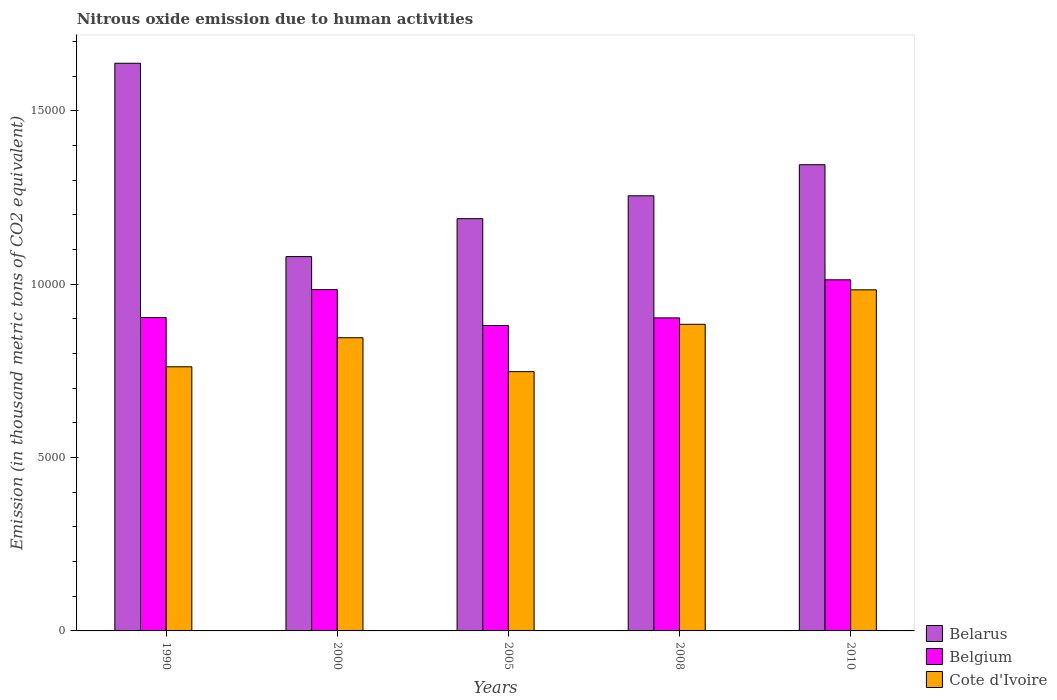What is the amount of nitrous oxide emitted in Belgium in 2010?
Your response must be concise. 1.01e+04. Across all years, what is the maximum amount of nitrous oxide emitted in Belarus?
Offer a very short reply. 1.64e+04. Across all years, what is the minimum amount of nitrous oxide emitted in Cote d'Ivoire?
Your response must be concise. 7477.7. In which year was the amount of nitrous oxide emitted in Belgium maximum?
Offer a terse response. 2010. In which year was the amount of nitrous oxide emitted in Belarus minimum?
Your answer should be compact. 2000. What is the total amount of nitrous oxide emitted in Belgium in the graph?
Make the answer very short. 4.68e+04. What is the difference between the amount of nitrous oxide emitted in Belarus in 2005 and that in 2010?
Give a very brief answer. -1555.5. What is the difference between the amount of nitrous oxide emitted in Belgium in 2000 and the amount of nitrous oxide emitted in Belarus in 2010?
Offer a very short reply. -3601.6. What is the average amount of nitrous oxide emitted in Belarus per year?
Offer a terse response. 1.30e+04. In the year 1990, what is the difference between the amount of nitrous oxide emitted in Cote d'Ivoire and amount of nitrous oxide emitted in Belarus?
Make the answer very short. -8754.3. In how many years, is the amount of nitrous oxide emitted in Belgium greater than 2000 thousand metric tons?
Your answer should be compact. 5. What is the ratio of the amount of nitrous oxide emitted in Belgium in 2000 to that in 2008?
Keep it short and to the point. 1.09. Is the amount of nitrous oxide emitted in Cote d'Ivoire in 1990 less than that in 2010?
Offer a terse response. Yes. Is the difference between the amount of nitrous oxide emitted in Cote d'Ivoire in 2008 and 2010 greater than the difference between the amount of nitrous oxide emitted in Belarus in 2008 and 2010?
Provide a short and direct response. No. What is the difference between the highest and the second highest amount of nitrous oxide emitted in Belgium?
Offer a terse response. 282.7. What is the difference between the highest and the lowest amount of nitrous oxide emitted in Belgium?
Give a very brief answer. 1318.2. In how many years, is the amount of nitrous oxide emitted in Cote d'Ivoire greater than the average amount of nitrous oxide emitted in Cote d'Ivoire taken over all years?
Offer a terse response. 3. Is the sum of the amount of nitrous oxide emitted in Belgium in 1990 and 2010 greater than the maximum amount of nitrous oxide emitted in Cote d'Ivoire across all years?
Your answer should be very brief. Yes. What does the 2nd bar from the left in 2000 represents?
Keep it short and to the point. Belgium. How many bars are there?
Ensure brevity in your answer.  15. What is the difference between two consecutive major ticks on the Y-axis?
Make the answer very short. 5000. Are the values on the major ticks of Y-axis written in scientific E-notation?
Ensure brevity in your answer.  No. Does the graph contain grids?
Provide a short and direct response. No. Where does the legend appear in the graph?
Make the answer very short. Bottom right. How many legend labels are there?
Keep it short and to the point. 3. How are the legend labels stacked?
Keep it short and to the point. Vertical. What is the title of the graph?
Ensure brevity in your answer.  Nitrous oxide emission due to human activities. Does "Nepal" appear as one of the legend labels in the graph?
Offer a very short reply. No. What is the label or title of the X-axis?
Provide a short and direct response. Years. What is the label or title of the Y-axis?
Offer a terse response. Emission (in thousand metric tons of CO2 equivalent). What is the Emission (in thousand metric tons of CO2 equivalent) of Belarus in 1990?
Offer a very short reply. 1.64e+04. What is the Emission (in thousand metric tons of CO2 equivalent) in Belgium in 1990?
Your answer should be very brief. 9037.7. What is the Emission (in thousand metric tons of CO2 equivalent) in Cote d'Ivoire in 1990?
Provide a short and direct response. 7618. What is the Emission (in thousand metric tons of CO2 equivalent) in Belarus in 2000?
Your answer should be compact. 1.08e+04. What is the Emission (in thousand metric tons of CO2 equivalent) in Belgium in 2000?
Provide a short and direct response. 9844.1. What is the Emission (in thousand metric tons of CO2 equivalent) in Cote d'Ivoire in 2000?
Ensure brevity in your answer.  8455.7. What is the Emission (in thousand metric tons of CO2 equivalent) in Belarus in 2005?
Give a very brief answer. 1.19e+04. What is the Emission (in thousand metric tons of CO2 equivalent) in Belgium in 2005?
Offer a very short reply. 8808.6. What is the Emission (in thousand metric tons of CO2 equivalent) in Cote d'Ivoire in 2005?
Keep it short and to the point. 7477.7. What is the Emission (in thousand metric tons of CO2 equivalent) of Belarus in 2008?
Ensure brevity in your answer.  1.25e+04. What is the Emission (in thousand metric tons of CO2 equivalent) of Belgium in 2008?
Offer a terse response. 9028.7. What is the Emission (in thousand metric tons of CO2 equivalent) in Cote d'Ivoire in 2008?
Provide a short and direct response. 8843.3. What is the Emission (in thousand metric tons of CO2 equivalent) in Belarus in 2010?
Make the answer very short. 1.34e+04. What is the Emission (in thousand metric tons of CO2 equivalent) in Belgium in 2010?
Provide a succinct answer. 1.01e+04. What is the Emission (in thousand metric tons of CO2 equivalent) of Cote d'Ivoire in 2010?
Provide a succinct answer. 9837.4. Across all years, what is the maximum Emission (in thousand metric tons of CO2 equivalent) of Belarus?
Offer a terse response. 1.64e+04. Across all years, what is the maximum Emission (in thousand metric tons of CO2 equivalent) in Belgium?
Keep it short and to the point. 1.01e+04. Across all years, what is the maximum Emission (in thousand metric tons of CO2 equivalent) in Cote d'Ivoire?
Provide a short and direct response. 9837.4. Across all years, what is the minimum Emission (in thousand metric tons of CO2 equivalent) of Belarus?
Your answer should be very brief. 1.08e+04. Across all years, what is the minimum Emission (in thousand metric tons of CO2 equivalent) in Belgium?
Your answer should be very brief. 8808.6. Across all years, what is the minimum Emission (in thousand metric tons of CO2 equivalent) in Cote d'Ivoire?
Make the answer very short. 7477.7. What is the total Emission (in thousand metric tons of CO2 equivalent) in Belarus in the graph?
Ensure brevity in your answer.  6.51e+04. What is the total Emission (in thousand metric tons of CO2 equivalent) of Belgium in the graph?
Your answer should be very brief. 4.68e+04. What is the total Emission (in thousand metric tons of CO2 equivalent) of Cote d'Ivoire in the graph?
Offer a very short reply. 4.22e+04. What is the difference between the Emission (in thousand metric tons of CO2 equivalent) in Belarus in 1990 and that in 2000?
Your response must be concise. 5576.4. What is the difference between the Emission (in thousand metric tons of CO2 equivalent) in Belgium in 1990 and that in 2000?
Offer a terse response. -806.4. What is the difference between the Emission (in thousand metric tons of CO2 equivalent) of Cote d'Ivoire in 1990 and that in 2000?
Your answer should be very brief. -837.7. What is the difference between the Emission (in thousand metric tons of CO2 equivalent) of Belarus in 1990 and that in 2005?
Offer a very short reply. 4482.1. What is the difference between the Emission (in thousand metric tons of CO2 equivalent) of Belgium in 1990 and that in 2005?
Your response must be concise. 229.1. What is the difference between the Emission (in thousand metric tons of CO2 equivalent) in Cote d'Ivoire in 1990 and that in 2005?
Keep it short and to the point. 140.3. What is the difference between the Emission (in thousand metric tons of CO2 equivalent) in Belarus in 1990 and that in 2008?
Make the answer very short. 3822.4. What is the difference between the Emission (in thousand metric tons of CO2 equivalent) of Belgium in 1990 and that in 2008?
Offer a terse response. 9. What is the difference between the Emission (in thousand metric tons of CO2 equivalent) of Cote d'Ivoire in 1990 and that in 2008?
Your answer should be compact. -1225.3. What is the difference between the Emission (in thousand metric tons of CO2 equivalent) in Belarus in 1990 and that in 2010?
Give a very brief answer. 2926.6. What is the difference between the Emission (in thousand metric tons of CO2 equivalent) in Belgium in 1990 and that in 2010?
Your answer should be very brief. -1089.1. What is the difference between the Emission (in thousand metric tons of CO2 equivalent) of Cote d'Ivoire in 1990 and that in 2010?
Your answer should be very brief. -2219.4. What is the difference between the Emission (in thousand metric tons of CO2 equivalent) in Belarus in 2000 and that in 2005?
Your answer should be very brief. -1094.3. What is the difference between the Emission (in thousand metric tons of CO2 equivalent) in Belgium in 2000 and that in 2005?
Your response must be concise. 1035.5. What is the difference between the Emission (in thousand metric tons of CO2 equivalent) of Cote d'Ivoire in 2000 and that in 2005?
Provide a short and direct response. 978. What is the difference between the Emission (in thousand metric tons of CO2 equivalent) in Belarus in 2000 and that in 2008?
Provide a short and direct response. -1754. What is the difference between the Emission (in thousand metric tons of CO2 equivalent) in Belgium in 2000 and that in 2008?
Provide a succinct answer. 815.4. What is the difference between the Emission (in thousand metric tons of CO2 equivalent) in Cote d'Ivoire in 2000 and that in 2008?
Give a very brief answer. -387.6. What is the difference between the Emission (in thousand metric tons of CO2 equivalent) of Belarus in 2000 and that in 2010?
Give a very brief answer. -2649.8. What is the difference between the Emission (in thousand metric tons of CO2 equivalent) of Belgium in 2000 and that in 2010?
Your response must be concise. -282.7. What is the difference between the Emission (in thousand metric tons of CO2 equivalent) of Cote d'Ivoire in 2000 and that in 2010?
Provide a short and direct response. -1381.7. What is the difference between the Emission (in thousand metric tons of CO2 equivalent) in Belarus in 2005 and that in 2008?
Your answer should be very brief. -659.7. What is the difference between the Emission (in thousand metric tons of CO2 equivalent) of Belgium in 2005 and that in 2008?
Offer a terse response. -220.1. What is the difference between the Emission (in thousand metric tons of CO2 equivalent) in Cote d'Ivoire in 2005 and that in 2008?
Your answer should be very brief. -1365.6. What is the difference between the Emission (in thousand metric tons of CO2 equivalent) in Belarus in 2005 and that in 2010?
Keep it short and to the point. -1555.5. What is the difference between the Emission (in thousand metric tons of CO2 equivalent) of Belgium in 2005 and that in 2010?
Your answer should be compact. -1318.2. What is the difference between the Emission (in thousand metric tons of CO2 equivalent) of Cote d'Ivoire in 2005 and that in 2010?
Keep it short and to the point. -2359.7. What is the difference between the Emission (in thousand metric tons of CO2 equivalent) in Belarus in 2008 and that in 2010?
Your answer should be very brief. -895.8. What is the difference between the Emission (in thousand metric tons of CO2 equivalent) in Belgium in 2008 and that in 2010?
Ensure brevity in your answer.  -1098.1. What is the difference between the Emission (in thousand metric tons of CO2 equivalent) in Cote d'Ivoire in 2008 and that in 2010?
Your answer should be very brief. -994.1. What is the difference between the Emission (in thousand metric tons of CO2 equivalent) of Belarus in 1990 and the Emission (in thousand metric tons of CO2 equivalent) of Belgium in 2000?
Your response must be concise. 6528.2. What is the difference between the Emission (in thousand metric tons of CO2 equivalent) in Belarus in 1990 and the Emission (in thousand metric tons of CO2 equivalent) in Cote d'Ivoire in 2000?
Your answer should be compact. 7916.6. What is the difference between the Emission (in thousand metric tons of CO2 equivalent) of Belgium in 1990 and the Emission (in thousand metric tons of CO2 equivalent) of Cote d'Ivoire in 2000?
Your response must be concise. 582. What is the difference between the Emission (in thousand metric tons of CO2 equivalent) in Belarus in 1990 and the Emission (in thousand metric tons of CO2 equivalent) in Belgium in 2005?
Your answer should be compact. 7563.7. What is the difference between the Emission (in thousand metric tons of CO2 equivalent) of Belarus in 1990 and the Emission (in thousand metric tons of CO2 equivalent) of Cote d'Ivoire in 2005?
Ensure brevity in your answer.  8894.6. What is the difference between the Emission (in thousand metric tons of CO2 equivalent) of Belgium in 1990 and the Emission (in thousand metric tons of CO2 equivalent) of Cote d'Ivoire in 2005?
Ensure brevity in your answer.  1560. What is the difference between the Emission (in thousand metric tons of CO2 equivalent) of Belarus in 1990 and the Emission (in thousand metric tons of CO2 equivalent) of Belgium in 2008?
Your response must be concise. 7343.6. What is the difference between the Emission (in thousand metric tons of CO2 equivalent) in Belarus in 1990 and the Emission (in thousand metric tons of CO2 equivalent) in Cote d'Ivoire in 2008?
Provide a short and direct response. 7529. What is the difference between the Emission (in thousand metric tons of CO2 equivalent) of Belgium in 1990 and the Emission (in thousand metric tons of CO2 equivalent) of Cote d'Ivoire in 2008?
Make the answer very short. 194.4. What is the difference between the Emission (in thousand metric tons of CO2 equivalent) of Belarus in 1990 and the Emission (in thousand metric tons of CO2 equivalent) of Belgium in 2010?
Your answer should be compact. 6245.5. What is the difference between the Emission (in thousand metric tons of CO2 equivalent) in Belarus in 1990 and the Emission (in thousand metric tons of CO2 equivalent) in Cote d'Ivoire in 2010?
Offer a very short reply. 6534.9. What is the difference between the Emission (in thousand metric tons of CO2 equivalent) of Belgium in 1990 and the Emission (in thousand metric tons of CO2 equivalent) of Cote d'Ivoire in 2010?
Keep it short and to the point. -799.7. What is the difference between the Emission (in thousand metric tons of CO2 equivalent) of Belarus in 2000 and the Emission (in thousand metric tons of CO2 equivalent) of Belgium in 2005?
Provide a succinct answer. 1987.3. What is the difference between the Emission (in thousand metric tons of CO2 equivalent) in Belarus in 2000 and the Emission (in thousand metric tons of CO2 equivalent) in Cote d'Ivoire in 2005?
Your answer should be very brief. 3318.2. What is the difference between the Emission (in thousand metric tons of CO2 equivalent) of Belgium in 2000 and the Emission (in thousand metric tons of CO2 equivalent) of Cote d'Ivoire in 2005?
Provide a succinct answer. 2366.4. What is the difference between the Emission (in thousand metric tons of CO2 equivalent) of Belarus in 2000 and the Emission (in thousand metric tons of CO2 equivalent) of Belgium in 2008?
Ensure brevity in your answer.  1767.2. What is the difference between the Emission (in thousand metric tons of CO2 equivalent) in Belarus in 2000 and the Emission (in thousand metric tons of CO2 equivalent) in Cote d'Ivoire in 2008?
Ensure brevity in your answer.  1952.6. What is the difference between the Emission (in thousand metric tons of CO2 equivalent) in Belgium in 2000 and the Emission (in thousand metric tons of CO2 equivalent) in Cote d'Ivoire in 2008?
Your answer should be very brief. 1000.8. What is the difference between the Emission (in thousand metric tons of CO2 equivalent) of Belarus in 2000 and the Emission (in thousand metric tons of CO2 equivalent) of Belgium in 2010?
Give a very brief answer. 669.1. What is the difference between the Emission (in thousand metric tons of CO2 equivalent) of Belarus in 2000 and the Emission (in thousand metric tons of CO2 equivalent) of Cote d'Ivoire in 2010?
Give a very brief answer. 958.5. What is the difference between the Emission (in thousand metric tons of CO2 equivalent) of Belarus in 2005 and the Emission (in thousand metric tons of CO2 equivalent) of Belgium in 2008?
Keep it short and to the point. 2861.5. What is the difference between the Emission (in thousand metric tons of CO2 equivalent) of Belarus in 2005 and the Emission (in thousand metric tons of CO2 equivalent) of Cote d'Ivoire in 2008?
Give a very brief answer. 3046.9. What is the difference between the Emission (in thousand metric tons of CO2 equivalent) in Belgium in 2005 and the Emission (in thousand metric tons of CO2 equivalent) in Cote d'Ivoire in 2008?
Give a very brief answer. -34.7. What is the difference between the Emission (in thousand metric tons of CO2 equivalent) in Belarus in 2005 and the Emission (in thousand metric tons of CO2 equivalent) in Belgium in 2010?
Give a very brief answer. 1763.4. What is the difference between the Emission (in thousand metric tons of CO2 equivalent) in Belarus in 2005 and the Emission (in thousand metric tons of CO2 equivalent) in Cote d'Ivoire in 2010?
Your answer should be compact. 2052.8. What is the difference between the Emission (in thousand metric tons of CO2 equivalent) in Belgium in 2005 and the Emission (in thousand metric tons of CO2 equivalent) in Cote d'Ivoire in 2010?
Provide a short and direct response. -1028.8. What is the difference between the Emission (in thousand metric tons of CO2 equivalent) of Belarus in 2008 and the Emission (in thousand metric tons of CO2 equivalent) of Belgium in 2010?
Your response must be concise. 2423.1. What is the difference between the Emission (in thousand metric tons of CO2 equivalent) in Belarus in 2008 and the Emission (in thousand metric tons of CO2 equivalent) in Cote d'Ivoire in 2010?
Your answer should be very brief. 2712.5. What is the difference between the Emission (in thousand metric tons of CO2 equivalent) of Belgium in 2008 and the Emission (in thousand metric tons of CO2 equivalent) of Cote d'Ivoire in 2010?
Your answer should be very brief. -808.7. What is the average Emission (in thousand metric tons of CO2 equivalent) in Belarus per year?
Your answer should be very brief. 1.30e+04. What is the average Emission (in thousand metric tons of CO2 equivalent) of Belgium per year?
Offer a terse response. 9369.18. What is the average Emission (in thousand metric tons of CO2 equivalent) of Cote d'Ivoire per year?
Your answer should be very brief. 8446.42. In the year 1990, what is the difference between the Emission (in thousand metric tons of CO2 equivalent) of Belarus and Emission (in thousand metric tons of CO2 equivalent) of Belgium?
Ensure brevity in your answer.  7334.6. In the year 1990, what is the difference between the Emission (in thousand metric tons of CO2 equivalent) of Belarus and Emission (in thousand metric tons of CO2 equivalent) of Cote d'Ivoire?
Your response must be concise. 8754.3. In the year 1990, what is the difference between the Emission (in thousand metric tons of CO2 equivalent) of Belgium and Emission (in thousand metric tons of CO2 equivalent) of Cote d'Ivoire?
Ensure brevity in your answer.  1419.7. In the year 2000, what is the difference between the Emission (in thousand metric tons of CO2 equivalent) of Belarus and Emission (in thousand metric tons of CO2 equivalent) of Belgium?
Make the answer very short. 951.8. In the year 2000, what is the difference between the Emission (in thousand metric tons of CO2 equivalent) of Belarus and Emission (in thousand metric tons of CO2 equivalent) of Cote d'Ivoire?
Provide a short and direct response. 2340.2. In the year 2000, what is the difference between the Emission (in thousand metric tons of CO2 equivalent) in Belgium and Emission (in thousand metric tons of CO2 equivalent) in Cote d'Ivoire?
Give a very brief answer. 1388.4. In the year 2005, what is the difference between the Emission (in thousand metric tons of CO2 equivalent) of Belarus and Emission (in thousand metric tons of CO2 equivalent) of Belgium?
Keep it short and to the point. 3081.6. In the year 2005, what is the difference between the Emission (in thousand metric tons of CO2 equivalent) in Belarus and Emission (in thousand metric tons of CO2 equivalent) in Cote d'Ivoire?
Your response must be concise. 4412.5. In the year 2005, what is the difference between the Emission (in thousand metric tons of CO2 equivalent) in Belgium and Emission (in thousand metric tons of CO2 equivalent) in Cote d'Ivoire?
Offer a terse response. 1330.9. In the year 2008, what is the difference between the Emission (in thousand metric tons of CO2 equivalent) of Belarus and Emission (in thousand metric tons of CO2 equivalent) of Belgium?
Keep it short and to the point. 3521.2. In the year 2008, what is the difference between the Emission (in thousand metric tons of CO2 equivalent) of Belarus and Emission (in thousand metric tons of CO2 equivalent) of Cote d'Ivoire?
Your response must be concise. 3706.6. In the year 2008, what is the difference between the Emission (in thousand metric tons of CO2 equivalent) of Belgium and Emission (in thousand metric tons of CO2 equivalent) of Cote d'Ivoire?
Provide a succinct answer. 185.4. In the year 2010, what is the difference between the Emission (in thousand metric tons of CO2 equivalent) in Belarus and Emission (in thousand metric tons of CO2 equivalent) in Belgium?
Your response must be concise. 3318.9. In the year 2010, what is the difference between the Emission (in thousand metric tons of CO2 equivalent) in Belarus and Emission (in thousand metric tons of CO2 equivalent) in Cote d'Ivoire?
Ensure brevity in your answer.  3608.3. In the year 2010, what is the difference between the Emission (in thousand metric tons of CO2 equivalent) in Belgium and Emission (in thousand metric tons of CO2 equivalent) in Cote d'Ivoire?
Give a very brief answer. 289.4. What is the ratio of the Emission (in thousand metric tons of CO2 equivalent) in Belarus in 1990 to that in 2000?
Offer a very short reply. 1.52. What is the ratio of the Emission (in thousand metric tons of CO2 equivalent) in Belgium in 1990 to that in 2000?
Ensure brevity in your answer.  0.92. What is the ratio of the Emission (in thousand metric tons of CO2 equivalent) in Cote d'Ivoire in 1990 to that in 2000?
Keep it short and to the point. 0.9. What is the ratio of the Emission (in thousand metric tons of CO2 equivalent) of Belarus in 1990 to that in 2005?
Your response must be concise. 1.38. What is the ratio of the Emission (in thousand metric tons of CO2 equivalent) in Belgium in 1990 to that in 2005?
Offer a very short reply. 1.03. What is the ratio of the Emission (in thousand metric tons of CO2 equivalent) in Cote d'Ivoire in 1990 to that in 2005?
Offer a very short reply. 1.02. What is the ratio of the Emission (in thousand metric tons of CO2 equivalent) of Belarus in 1990 to that in 2008?
Keep it short and to the point. 1.3. What is the ratio of the Emission (in thousand metric tons of CO2 equivalent) in Belgium in 1990 to that in 2008?
Make the answer very short. 1. What is the ratio of the Emission (in thousand metric tons of CO2 equivalent) in Cote d'Ivoire in 1990 to that in 2008?
Keep it short and to the point. 0.86. What is the ratio of the Emission (in thousand metric tons of CO2 equivalent) in Belarus in 1990 to that in 2010?
Offer a very short reply. 1.22. What is the ratio of the Emission (in thousand metric tons of CO2 equivalent) of Belgium in 1990 to that in 2010?
Give a very brief answer. 0.89. What is the ratio of the Emission (in thousand metric tons of CO2 equivalent) in Cote d'Ivoire in 1990 to that in 2010?
Ensure brevity in your answer.  0.77. What is the ratio of the Emission (in thousand metric tons of CO2 equivalent) in Belarus in 2000 to that in 2005?
Provide a succinct answer. 0.91. What is the ratio of the Emission (in thousand metric tons of CO2 equivalent) in Belgium in 2000 to that in 2005?
Provide a succinct answer. 1.12. What is the ratio of the Emission (in thousand metric tons of CO2 equivalent) in Cote d'Ivoire in 2000 to that in 2005?
Provide a short and direct response. 1.13. What is the ratio of the Emission (in thousand metric tons of CO2 equivalent) of Belarus in 2000 to that in 2008?
Keep it short and to the point. 0.86. What is the ratio of the Emission (in thousand metric tons of CO2 equivalent) in Belgium in 2000 to that in 2008?
Provide a succinct answer. 1.09. What is the ratio of the Emission (in thousand metric tons of CO2 equivalent) of Cote d'Ivoire in 2000 to that in 2008?
Keep it short and to the point. 0.96. What is the ratio of the Emission (in thousand metric tons of CO2 equivalent) in Belarus in 2000 to that in 2010?
Offer a very short reply. 0.8. What is the ratio of the Emission (in thousand metric tons of CO2 equivalent) in Belgium in 2000 to that in 2010?
Your answer should be compact. 0.97. What is the ratio of the Emission (in thousand metric tons of CO2 equivalent) in Cote d'Ivoire in 2000 to that in 2010?
Your response must be concise. 0.86. What is the ratio of the Emission (in thousand metric tons of CO2 equivalent) in Belarus in 2005 to that in 2008?
Offer a very short reply. 0.95. What is the ratio of the Emission (in thousand metric tons of CO2 equivalent) of Belgium in 2005 to that in 2008?
Give a very brief answer. 0.98. What is the ratio of the Emission (in thousand metric tons of CO2 equivalent) of Cote d'Ivoire in 2005 to that in 2008?
Provide a succinct answer. 0.85. What is the ratio of the Emission (in thousand metric tons of CO2 equivalent) of Belarus in 2005 to that in 2010?
Your answer should be compact. 0.88. What is the ratio of the Emission (in thousand metric tons of CO2 equivalent) in Belgium in 2005 to that in 2010?
Your response must be concise. 0.87. What is the ratio of the Emission (in thousand metric tons of CO2 equivalent) in Cote d'Ivoire in 2005 to that in 2010?
Your answer should be very brief. 0.76. What is the ratio of the Emission (in thousand metric tons of CO2 equivalent) of Belarus in 2008 to that in 2010?
Offer a very short reply. 0.93. What is the ratio of the Emission (in thousand metric tons of CO2 equivalent) in Belgium in 2008 to that in 2010?
Make the answer very short. 0.89. What is the ratio of the Emission (in thousand metric tons of CO2 equivalent) in Cote d'Ivoire in 2008 to that in 2010?
Make the answer very short. 0.9. What is the difference between the highest and the second highest Emission (in thousand metric tons of CO2 equivalent) of Belarus?
Provide a short and direct response. 2926.6. What is the difference between the highest and the second highest Emission (in thousand metric tons of CO2 equivalent) in Belgium?
Give a very brief answer. 282.7. What is the difference between the highest and the second highest Emission (in thousand metric tons of CO2 equivalent) of Cote d'Ivoire?
Provide a short and direct response. 994.1. What is the difference between the highest and the lowest Emission (in thousand metric tons of CO2 equivalent) in Belarus?
Your response must be concise. 5576.4. What is the difference between the highest and the lowest Emission (in thousand metric tons of CO2 equivalent) of Belgium?
Your answer should be very brief. 1318.2. What is the difference between the highest and the lowest Emission (in thousand metric tons of CO2 equivalent) of Cote d'Ivoire?
Make the answer very short. 2359.7. 